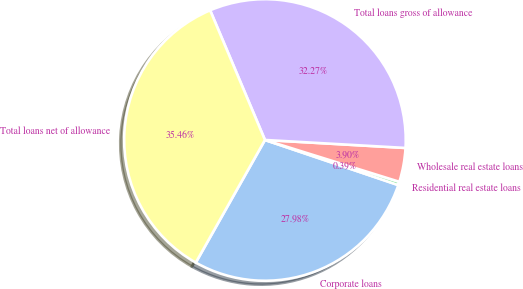<chart> <loc_0><loc_0><loc_500><loc_500><pie_chart><fcel>Corporate loans<fcel>Residential real estate loans<fcel>Wholesale real estate loans<fcel>Total loans gross of allowance<fcel>Total loans net of allowance<nl><fcel>27.98%<fcel>0.39%<fcel>3.9%<fcel>32.27%<fcel>35.46%<nl></chart> 